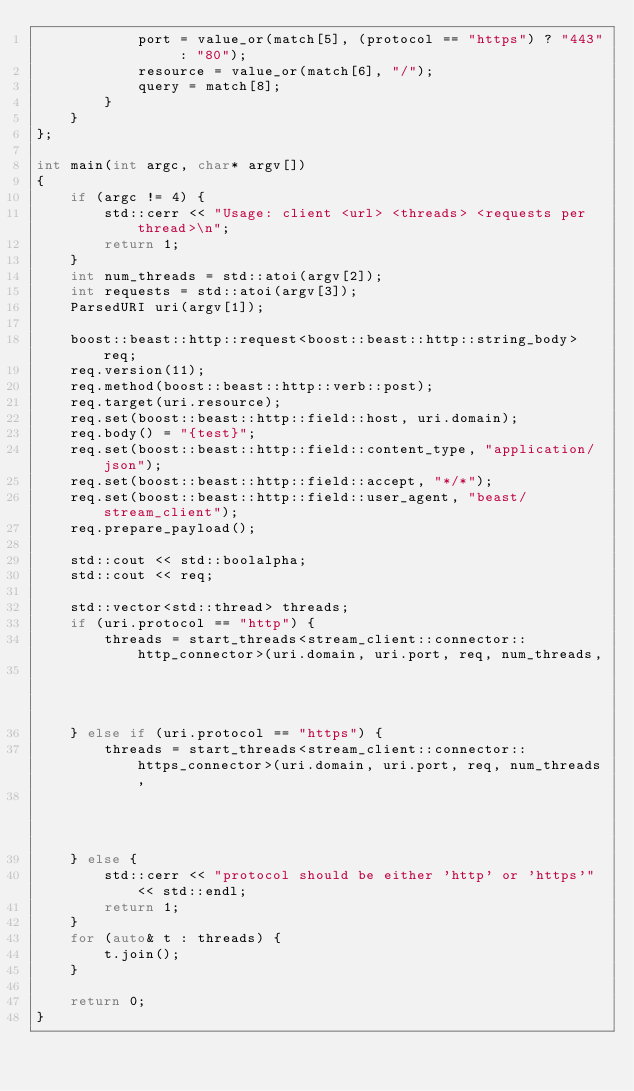Convert code to text. <code><loc_0><loc_0><loc_500><loc_500><_C++_>            port = value_or(match[5], (protocol == "https") ? "443" : "80");
            resource = value_or(match[6], "/");
            query = match[8];
        }
    }
};

int main(int argc, char* argv[])
{
    if (argc != 4) {
        std::cerr << "Usage: client <url> <threads> <requests per thread>\n";
        return 1;
    }
    int num_threads = std::atoi(argv[2]);
    int requests = std::atoi(argv[3]);
    ParsedURI uri(argv[1]);

    boost::beast::http::request<boost::beast::http::string_body> req;
    req.version(11);
    req.method(boost::beast::http::verb::post);
    req.target(uri.resource);
    req.set(boost::beast::http::field::host, uri.domain);
    req.body() = "{test}";
    req.set(boost::beast::http::field::content_type, "application/json");
    req.set(boost::beast::http::field::accept, "*/*");
    req.set(boost::beast::http::field::user_agent, "beast/stream_client");
    req.prepare_payload();

    std::cout << std::boolalpha;
    std::cout << req;

    std::vector<std::thread> threads;
    if (uri.protocol == "http") {
        threads = start_threads<stream_client::connector::http_connector>(uri.domain, uri.port, req, num_threads,
                                                                          requests);
    } else if (uri.protocol == "https") {
        threads = start_threads<stream_client::connector::https_connector>(uri.domain, uri.port, req, num_threads,
                                                                           requests);
    } else {
        std::cerr << "protocol should be either 'http' or 'https'" << std::endl;
        return 1;
    }
    for (auto& t : threads) {
        t.join();
    }

    return 0;
}
</code> 